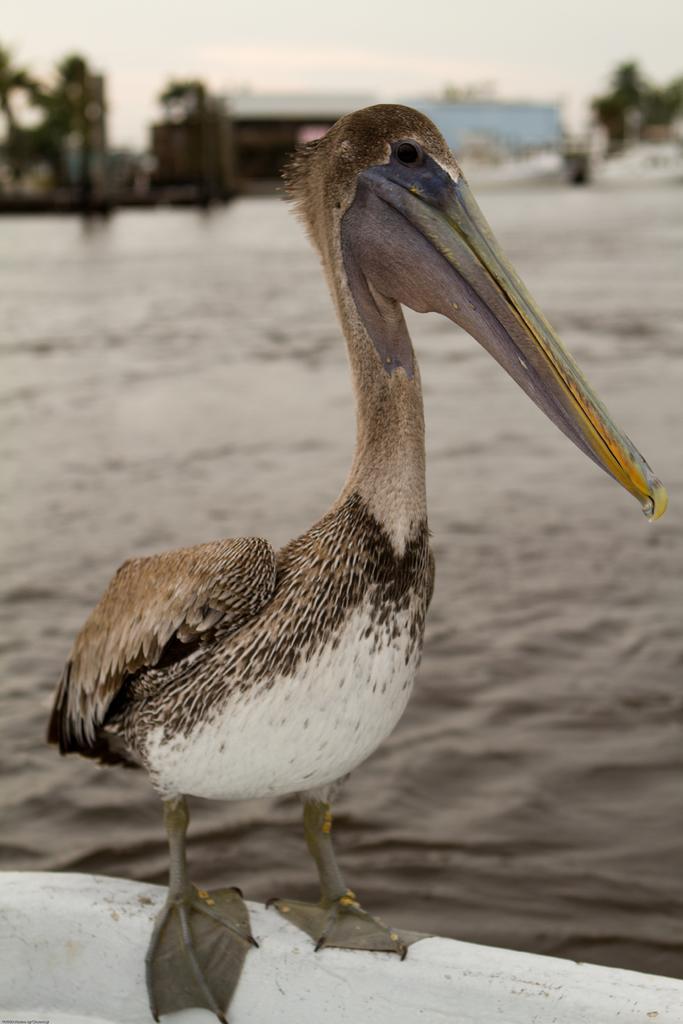How would you summarize this image in a sentence or two? In this picture I can see a bird is standing. In the background I can see water, the sky and some other objects. 